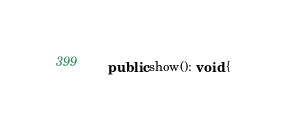<code> <loc_0><loc_0><loc_500><loc_500><_TypeScript_>
    public show(): void {</code> 